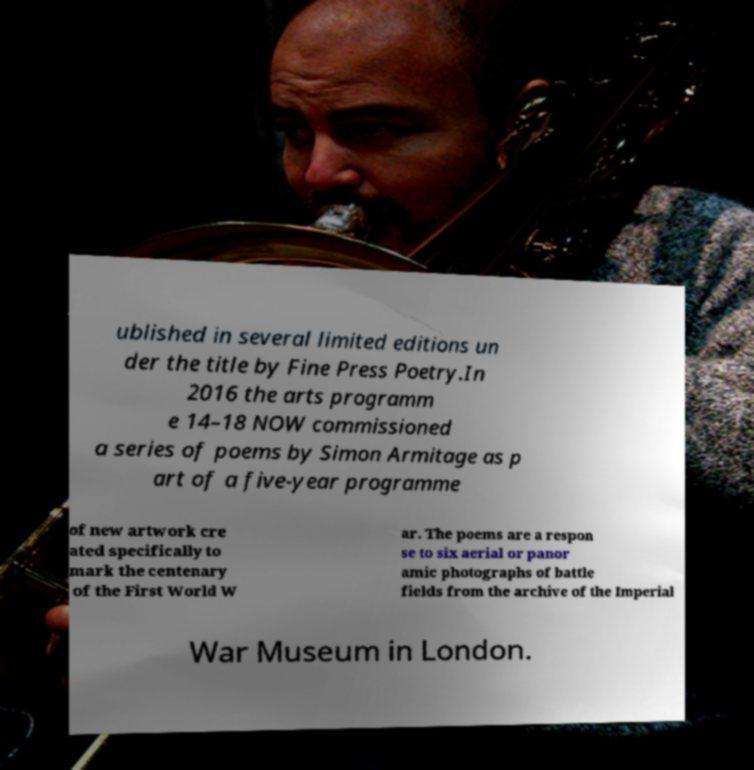What messages or text are displayed in this image? I need them in a readable, typed format. ublished in several limited editions un der the title by Fine Press Poetry.In 2016 the arts programm e 14–18 NOW commissioned a series of poems by Simon Armitage as p art of a five-year programme of new artwork cre ated specifically to mark the centenary of the First World W ar. The poems are a respon se to six aerial or panor amic photographs of battle fields from the archive of the Imperial War Museum in London. 